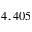<formula> <loc_0><loc_0><loc_500><loc_500>4 , 4 0 5</formula> 